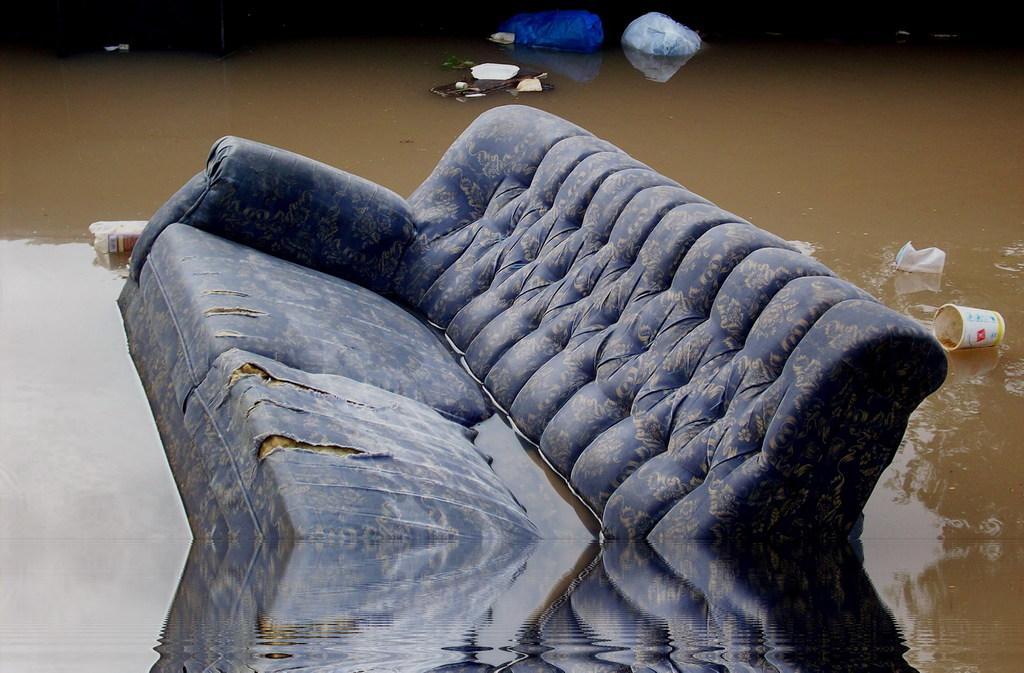Describe this image in one or two sentences. In this picture we can see a sofa in the water, in the background we can see plastic covers, bottle and a cup on the water. 